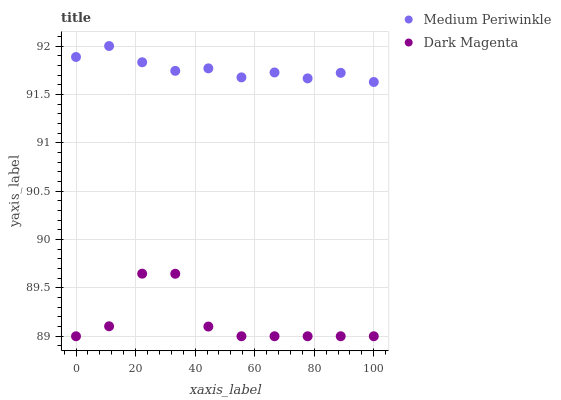Does Dark Magenta have the minimum area under the curve?
Answer yes or no. Yes. Does Medium Periwinkle have the maximum area under the curve?
Answer yes or no. Yes. Does Dark Magenta have the maximum area under the curve?
Answer yes or no. No. Is Medium Periwinkle the smoothest?
Answer yes or no. Yes. Is Dark Magenta the roughest?
Answer yes or no. Yes. Is Dark Magenta the smoothest?
Answer yes or no. No. Does Dark Magenta have the lowest value?
Answer yes or no. Yes. Does Medium Periwinkle have the highest value?
Answer yes or no. Yes. Does Dark Magenta have the highest value?
Answer yes or no. No. Is Dark Magenta less than Medium Periwinkle?
Answer yes or no. Yes. Is Medium Periwinkle greater than Dark Magenta?
Answer yes or no. Yes. Does Dark Magenta intersect Medium Periwinkle?
Answer yes or no. No. 